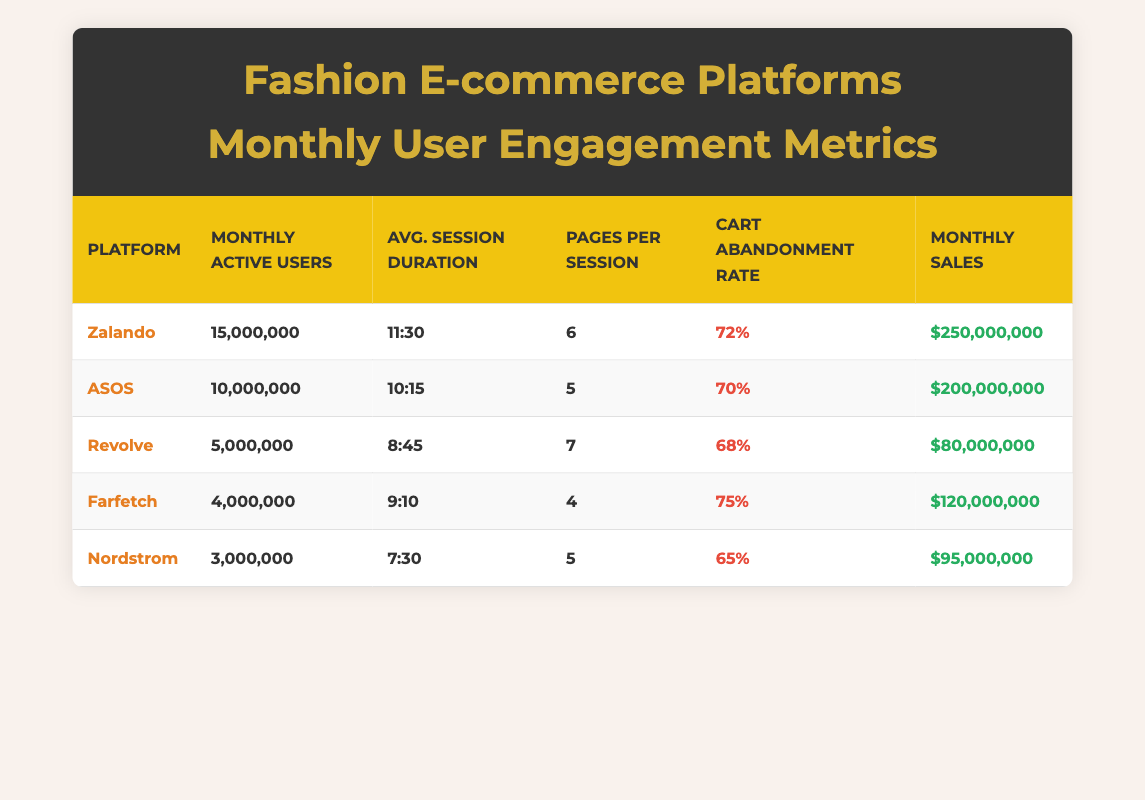What is the Monthly Active Users count for Zalando? The table lists the Monthly Active Users for each platform. For Zalando, it shows the value as 15,000,000.
Answer: 15,000,000 What is the Average Session Duration for ASOS compared to Revolve? The Average Session Duration for ASOS is listed as 10:15 and for Revolve, it's 8:45. This shows ASOS has a longer session duration than Revolve.
Answer: ASOS has a longer session duration Which platform has the highest Cart Abandonment Rate? In the table, the Cart Abandonment Rates are compared, and the highest value is for Farfetch at 75%.
Answer: Farfetch What are the Monthly Sales for Nordstrom and how do they compare to Farfetch? The Monthly Sales for Nordstrom are $95,000,000 and for Farfetch, they are $120,000,000. When compared, Farfetch has higher sales than Nordstrom.
Answer: Farfetch has higher sales What is the total Monthly Active Users for all platforms combined? The Monthly Active Users for each platform are summed up: 15,000,000 (Zalando) + 10,000,000 (ASOS) + 5,000,000 (Revolve) + 4,000,000 (Farfetch) + 3,000,000 (Nordstrom) = 37,000,000.
Answer: 37,000,000 Is the Average Session Duration for Nordstrom greater than that of ASOS? The table lists Nordstrom's Average Session Duration as 7:30 and ASOS's as 10:15. Since 7:30 is less than 10:15, the statement is false.
Answer: No Which platform has the lowest Monthly Sales? By checking the Monthly Sales figures, Revolve is noted to have the lowest at $80,000,000.
Answer: Revolve If we consider the average Cart Abandonment Rate across all platforms, what would it be? The Cart Abandonment Rates are 72% (Zalando), 70% (ASOS), 68% (Revolve), 75% (Farfetch), and 65% (Nordstrom). Adding these gives 72 + 70 + 68 + 75 + 65 = 350. Dividing by 5 gives an average of 70%.
Answer: 70% What is the relationship between Monthly Active Users and Monthly Sales for ASOS? The table shows ASOS with 10,000,000 Monthly Active Users and $200,000,000 in Monthly Sales, indicating a positive relationship as higher active users correspond with higher sales.
Answer: Positive relationship 